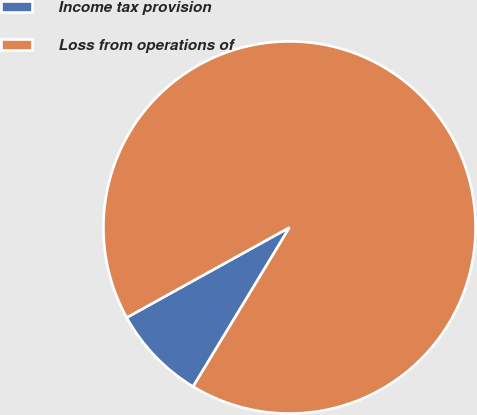Convert chart to OTSL. <chart><loc_0><loc_0><loc_500><loc_500><pie_chart><fcel>Income tax provision<fcel>Loss from operations of<nl><fcel>8.29%<fcel>91.71%<nl></chart> 